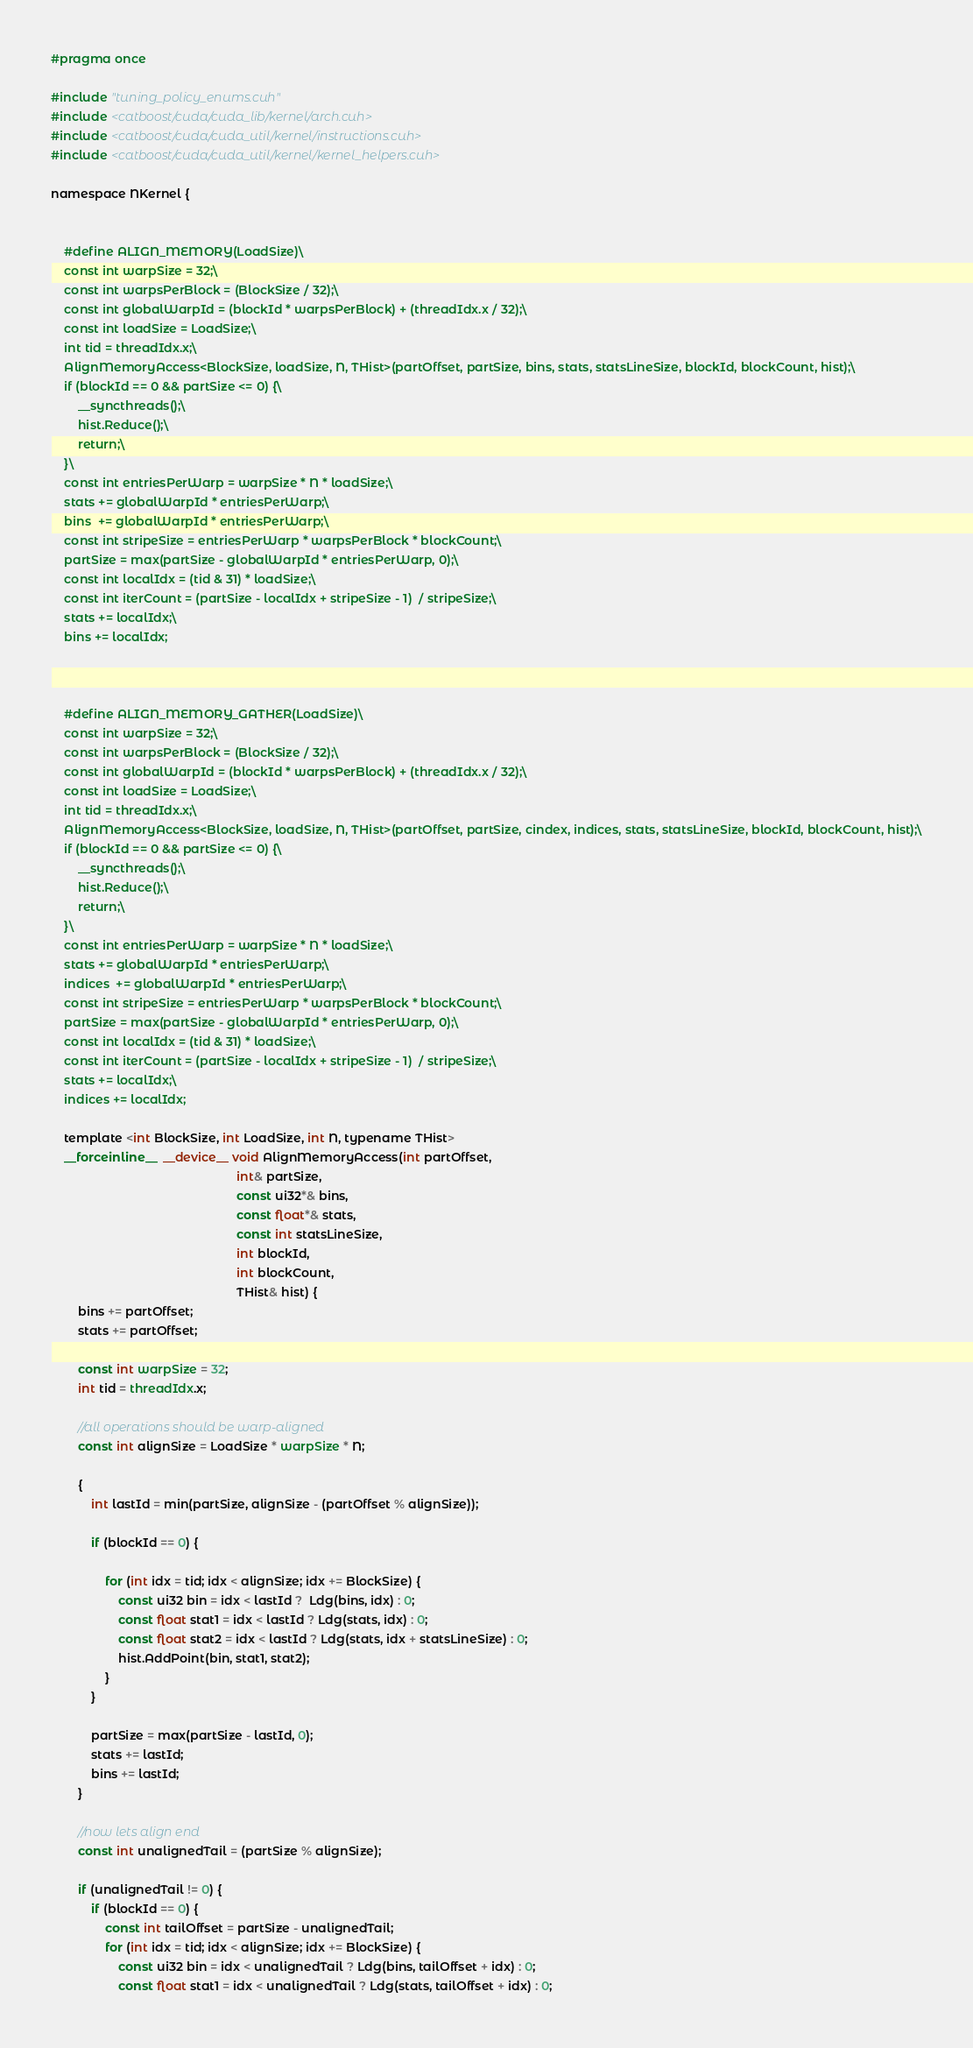<code> <loc_0><loc_0><loc_500><loc_500><_Cuda_>#pragma once

#include "tuning_policy_enums.cuh"
#include <catboost/cuda/cuda_lib/kernel/arch.cuh>
#include <catboost/cuda/cuda_util/kernel/instructions.cuh>
#include <catboost/cuda/cuda_util/kernel/kernel_helpers.cuh>

namespace NKernel {


    #define ALIGN_MEMORY(LoadSize)\
    const int warpSize = 32;\
    const int warpsPerBlock = (BlockSize / 32);\
    const int globalWarpId = (blockId * warpsPerBlock) + (threadIdx.x / 32);\
    const int loadSize = LoadSize;\
    int tid = threadIdx.x;\
    AlignMemoryAccess<BlockSize, loadSize, N, THist>(partOffset, partSize, bins, stats, statsLineSize, blockId, blockCount, hist);\
    if (blockId == 0 && partSize <= 0) {\
        __syncthreads();\
        hist.Reduce();\
        return;\
    }\
    const int entriesPerWarp = warpSize * N * loadSize;\
    stats += globalWarpId * entriesPerWarp;\
    bins  += globalWarpId * entriesPerWarp;\
    const int stripeSize = entriesPerWarp * warpsPerBlock * blockCount;\
    partSize = max(partSize - globalWarpId * entriesPerWarp, 0);\
    const int localIdx = (tid & 31) * loadSize;\
    const int iterCount = (partSize - localIdx + stripeSize - 1)  / stripeSize;\
    stats += localIdx;\
    bins += localIdx;



    #define ALIGN_MEMORY_GATHER(LoadSize)\
    const int warpSize = 32;\
    const int warpsPerBlock = (BlockSize / 32);\
    const int globalWarpId = (blockId * warpsPerBlock) + (threadIdx.x / 32);\
    const int loadSize = LoadSize;\
    int tid = threadIdx.x;\
    AlignMemoryAccess<BlockSize, loadSize, N, THist>(partOffset, partSize, cindex, indices, stats, statsLineSize, blockId, blockCount, hist);\
    if (blockId == 0 && partSize <= 0) {\
        __syncthreads();\
        hist.Reduce();\
        return;\
    }\
    const int entriesPerWarp = warpSize * N * loadSize;\
    stats += globalWarpId * entriesPerWarp;\
    indices  += globalWarpId * entriesPerWarp;\
    const int stripeSize = entriesPerWarp * warpsPerBlock * blockCount;\
    partSize = max(partSize - globalWarpId * entriesPerWarp, 0);\
    const int localIdx = (tid & 31) * loadSize;\
    const int iterCount = (partSize - localIdx + stripeSize - 1)  / stripeSize;\
    stats += localIdx;\
    indices += localIdx;

    template <int BlockSize, int LoadSize, int N, typename THist>
    __forceinline__  __device__ void AlignMemoryAccess(int partOffset,
                                                       int& partSize,
                                                       const ui32*& bins,
                                                       const float*& stats,
                                                       const int statsLineSize,
                                                       int blockId,
                                                       int blockCount,
                                                       THist& hist) {
        bins += partOffset;
        stats += partOffset;

        const int warpSize = 32;
        int tid = threadIdx.x;

        //all operations should be warp-aligned
        const int alignSize = LoadSize * warpSize * N;

        {
            int lastId = min(partSize, alignSize - (partOffset % alignSize));

            if (blockId == 0) {

                for (int idx = tid; idx < alignSize; idx += BlockSize) {
                    const ui32 bin = idx < lastId ?  Ldg(bins, idx) : 0;
                    const float stat1 = idx < lastId ? Ldg(stats, idx) : 0;
                    const float stat2 = idx < lastId ? Ldg(stats, idx + statsLineSize) : 0;
                    hist.AddPoint(bin, stat1, stat2);
                }
            }

            partSize = max(partSize - lastId, 0);
            stats += lastId;
            bins += lastId;
        }

        //now lets align end
        const int unalignedTail = (partSize % alignSize);

        if (unalignedTail != 0) {
            if (blockId == 0) {
                const int tailOffset = partSize - unalignedTail;
                for (int idx = tid; idx < alignSize; idx += BlockSize) {
                    const ui32 bin = idx < unalignedTail ? Ldg(bins, tailOffset + idx) : 0;
                    const float stat1 = idx < unalignedTail ? Ldg(stats, tailOffset + idx) : 0;</code> 